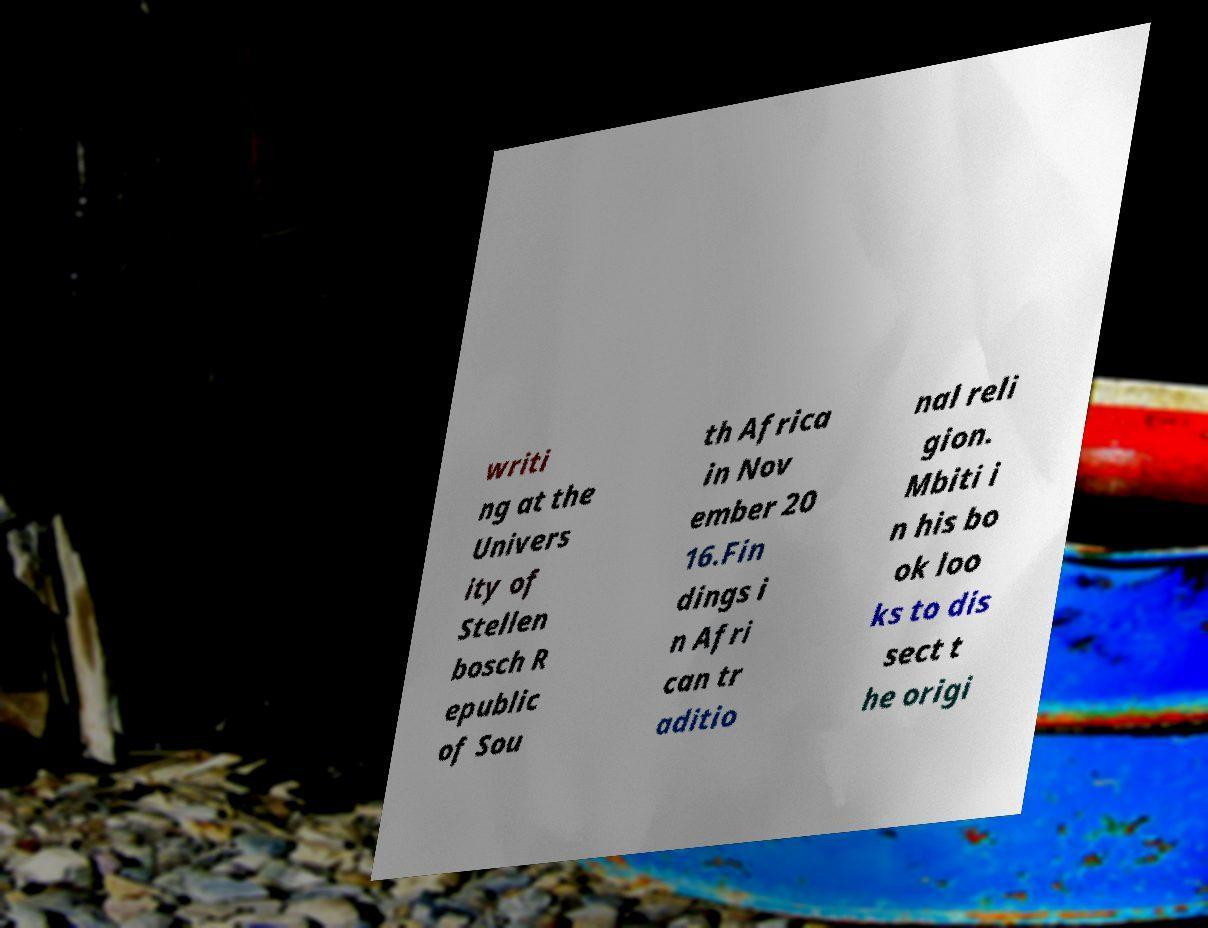Can you read and provide the text displayed in the image?This photo seems to have some interesting text. Can you extract and type it out for me? writi ng at the Univers ity of Stellen bosch R epublic of Sou th Africa in Nov ember 20 16.Fin dings i n Afri can tr aditio nal reli gion. Mbiti i n his bo ok loo ks to dis sect t he origi 